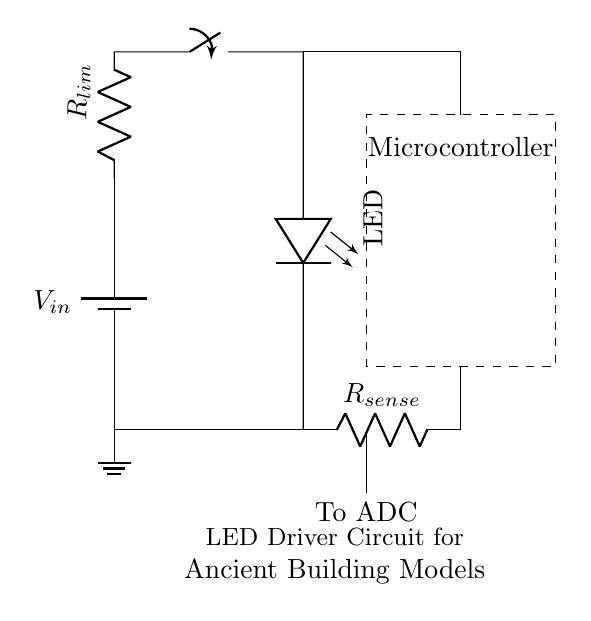What is the voltage source in this circuit? The voltage source in this circuit is indicated by the battery symbol labeled as V_in, which provides the power supply.
Answer: V_in What does R_lim do in this circuit? R_lim is the current limiting resistor that ensures the LED operates safely by controlling the amount of current flowing through it.
Answer: Current limiting How many resistors are present in the circuit? There are two resistors in the circuit: R_lim and R_sense.
Answer: Two What component is used for current sensing? R_sense is used for current sensing in the circuit, as it measures the current flowing through the LED for feedback to the microcontroller.
Answer: R_sense What type of microcontroller is indicated in the circuit? The circuit shows a dashed rectangle labeled "Microcontroller," representing the component responsible for controlling the LED's operation based on current feedback.
Answer: Microcontroller How is the LED connected in the circuit? The LED is connected in series with the current limiting resistor R_lim and the power supply, ensuring it receives the correct voltage and current for illumination.
Answer: In series Where does the output from the microcontroller go? The output from the microcontroller is connected to the switch in the circuit, which controls the flow of current to the LED when turned on.
Answer: To the switch 